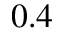<formula> <loc_0><loc_0><loc_500><loc_500>0 . 4</formula> 